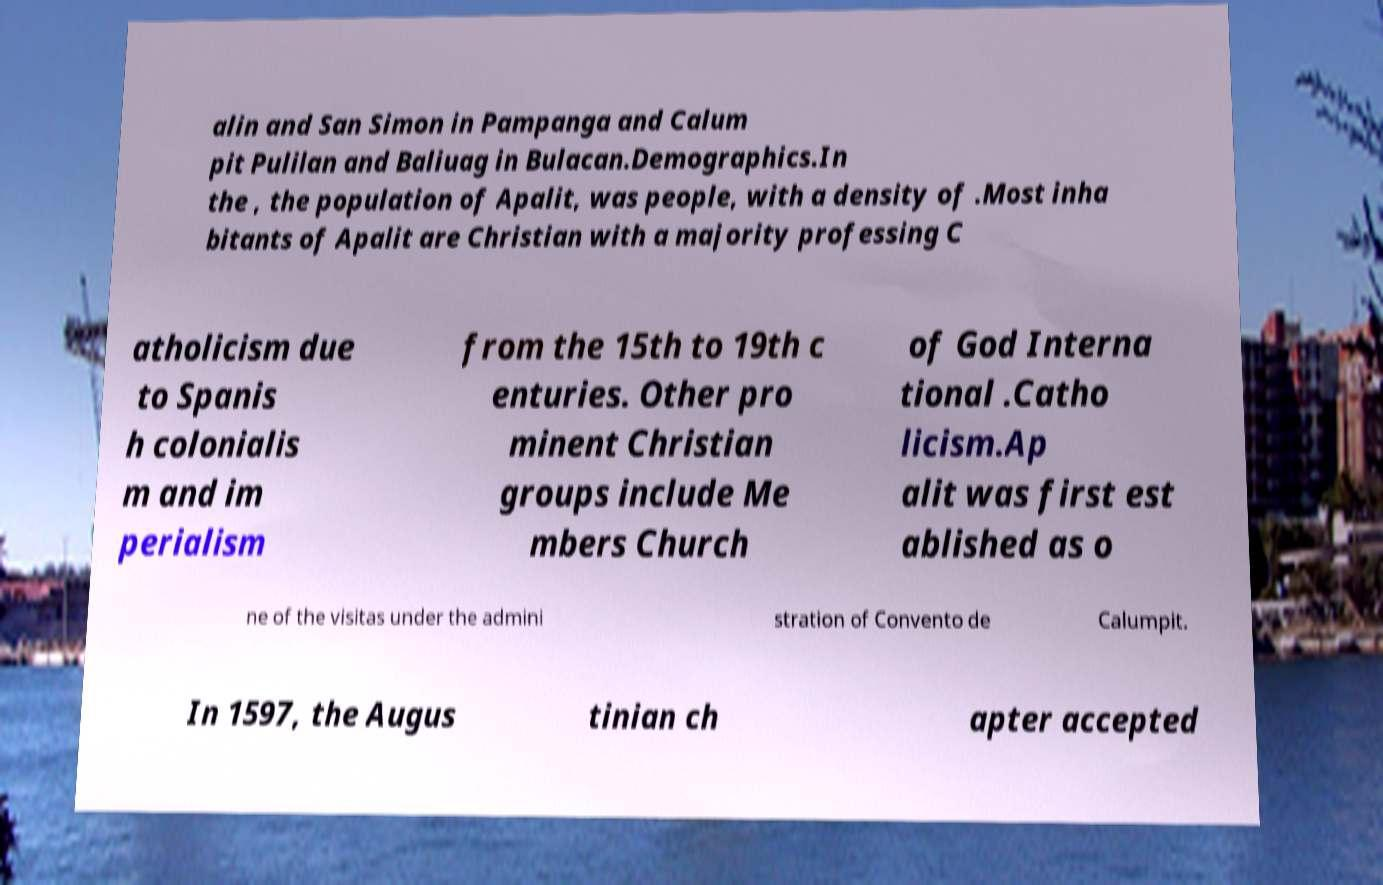Can you accurately transcribe the text from the provided image for me? alin and San Simon in Pampanga and Calum pit Pulilan and Baliuag in Bulacan.Demographics.In the , the population of Apalit, was people, with a density of .Most inha bitants of Apalit are Christian with a majority professing C atholicism due to Spanis h colonialis m and im perialism from the 15th to 19th c enturies. Other pro minent Christian groups include Me mbers Church of God Interna tional .Catho licism.Ap alit was first est ablished as o ne of the visitas under the admini stration of Convento de Calumpit. In 1597, the Augus tinian ch apter accepted 